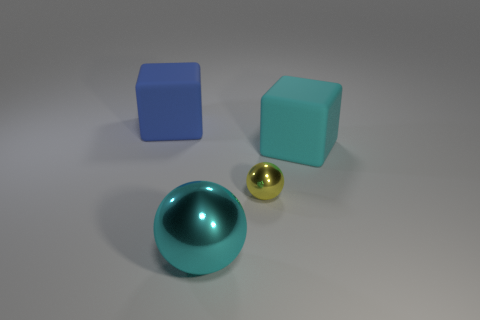Does the cyan object right of the tiny yellow sphere have the same material as the blue thing?
Your answer should be very brief. Yes. What shape is the yellow metal object?
Offer a terse response. Sphere. How many cyan objects are matte things or small things?
Your answer should be very brief. 1. What number of other objects are there of the same material as the large sphere?
Your answer should be very brief. 1. There is a large matte object to the right of the big blue matte block; is its shape the same as the yellow object?
Offer a very short reply. No. Are there any spheres?
Your answer should be compact. Yes. Are there any other things that have the same shape as the big cyan metallic thing?
Provide a succinct answer. Yes. Is the number of big cyan cubes to the left of the small shiny sphere greater than the number of cyan rubber things?
Make the answer very short. No. There is a cyan metallic ball; are there any shiny objects on the right side of it?
Offer a terse response. Yes. Do the blue cube and the yellow sphere have the same size?
Keep it short and to the point. No. 